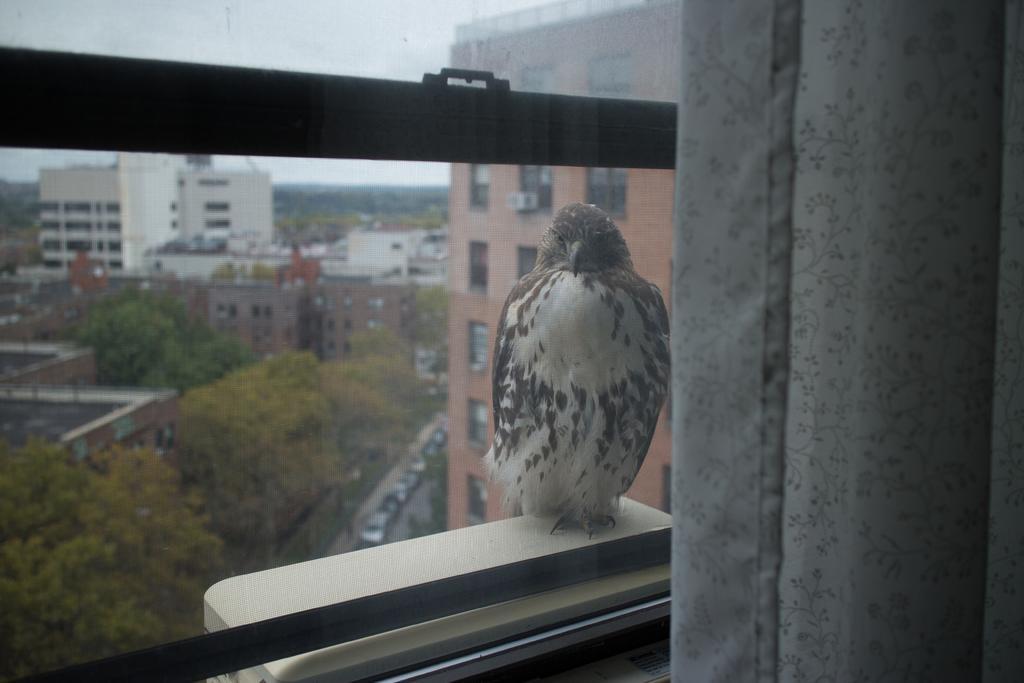Could you give a brief overview of what you see in this image? In this image we can see a bird standing on the window wall. In the background there are buildings, trees and sky. 